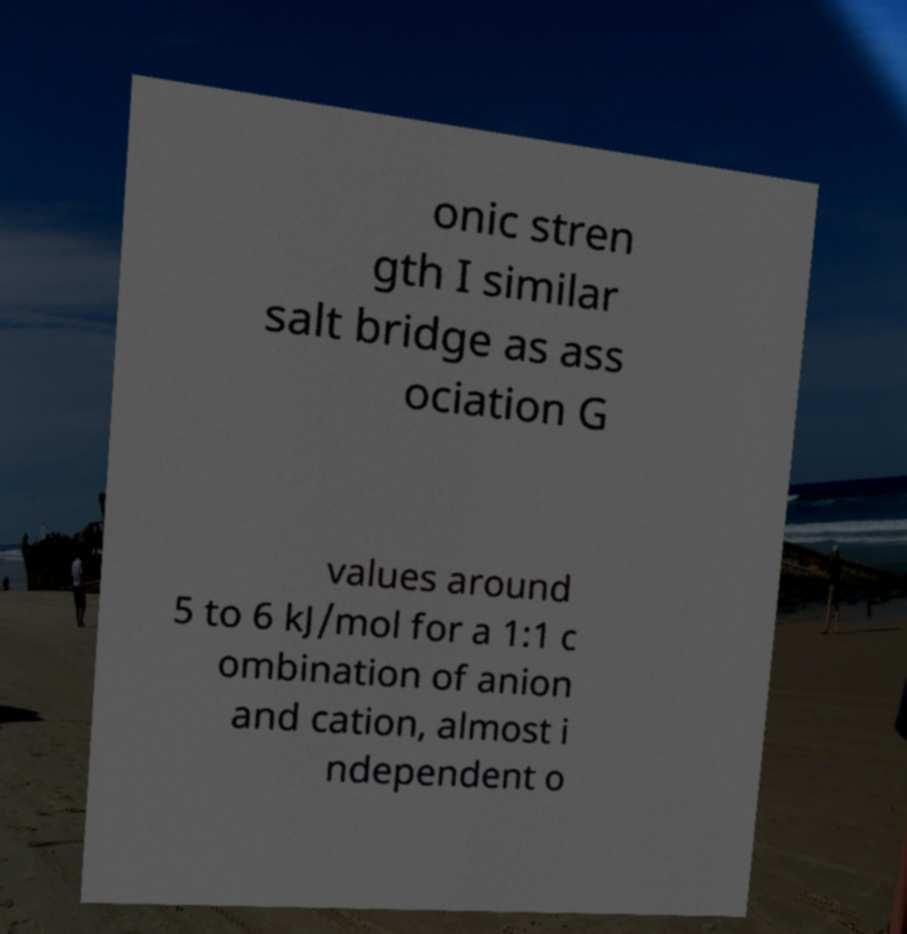I need the written content from this picture converted into text. Can you do that? onic stren gth I similar salt bridge as ass ociation G values around 5 to 6 kJ/mol for a 1:1 c ombination of anion and cation, almost i ndependent o 